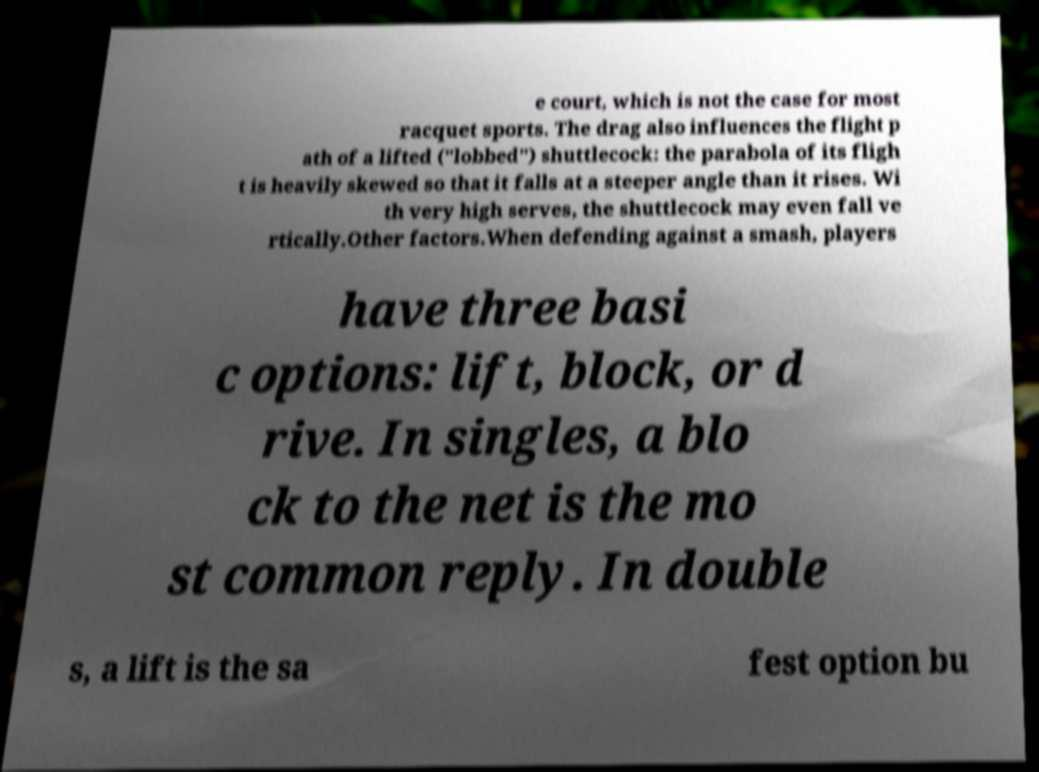What messages or text are displayed in this image? I need them in a readable, typed format. e court, which is not the case for most racquet sports. The drag also influences the flight p ath of a lifted ("lobbed") shuttlecock: the parabola of its fligh t is heavily skewed so that it falls at a steeper angle than it rises. Wi th very high serves, the shuttlecock may even fall ve rtically.Other factors.When defending against a smash, players have three basi c options: lift, block, or d rive. In singles, a blo ck to the net is the mo st common reply. In double s, a lift is the sa fest option bu 